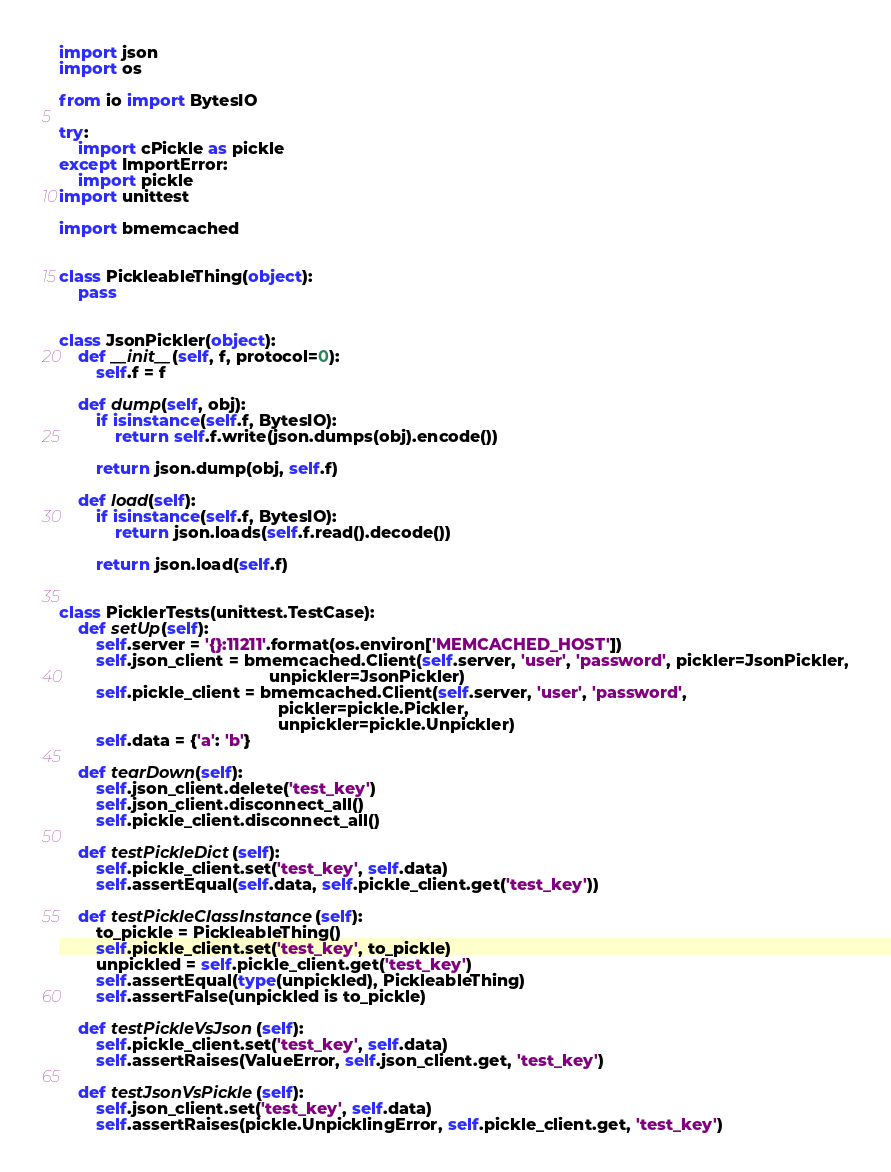<code> <loc_0><loc_0><loc_500><loc_500><_Python_>import json
import os

from io import BytesIO

try:
    import cPickle as pickle
except ImportError:
    import pickle
import unittest

import bmemcached


class PickleableThing(object):
    pass


class JsonPickler(object):
    def __init__(self, f, protocol=0):
        self.f = f

    def dump(self, obj):
        if isinstance(self.f, BytesIO):
            return self.f.write(json.dumps(obj).encode())

        return json.dump(obj, self.f)

    def load(self):
        if isinstance(self.f, BytesIO):
            return json.loads(self.f.read().decode())

        return json.load(self.f)


class PicklerTests(unittest.TestCase):
    def setUp(self):
        self.server = '{}:11211'.format(os.environ['MEMCACHED_HOST'])
        self.json_client = bmemcached.Client(self.server, 'user', 'password', pickler=JsonPickler,
                                             unpickler=JsonPickler)
        self.pickle_client = bmemcached.Client(self.server, 'user', 'password',
                                               pickler=pickle.Pickler,
                                               unpickler=pickle.Unpickler)
        self.data = {'a': 'b'}

    def tearDown(self):
        self.json_client.delete('test_key')
        self.json_client.disconnect_all()
        self.pickle_client.disconnect_all()

    def testPickleDict(self):
        self.pickle_client.set('test_key', self.data)
        self.assertEqual(self.data, self.pickle_client.get('test_key'))

    def testPickleClassInstance(self):
        to_pickle = PickleableThing()
        self.pickle_client.set('test_key', to_pickle)
        unpickled = self.pickle_client.get('test_key')
        self.assertEqual(type(unpickled), PickleableThing)
        self.assertFalse(unpickled is to_pickle)

    def testPickleVsJson(self):
        self.pickle_client.set('test_key', self.data)
        self.assertRaises(ValueError, self.json_client.get, 'test_key')

    def testJsonVsPickle(self):
        self.json_client.set('test_key', self.data)
        self.assertRaises(pickle.UnpicklingError, self.pickle_client.get, 'test_key')
</code> 